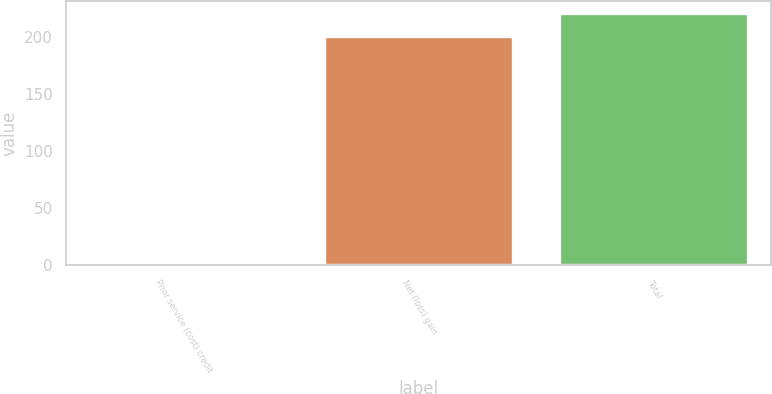Convert chart. <chart><loc_0><loc_0><loc_500><loc_500><bar_chart><fcel>Prior service (cost) credit<fcel>Net (loss) gain<fcel>Total<nl><fcel>2<fcel>200<fcel>220<nl></chart> 